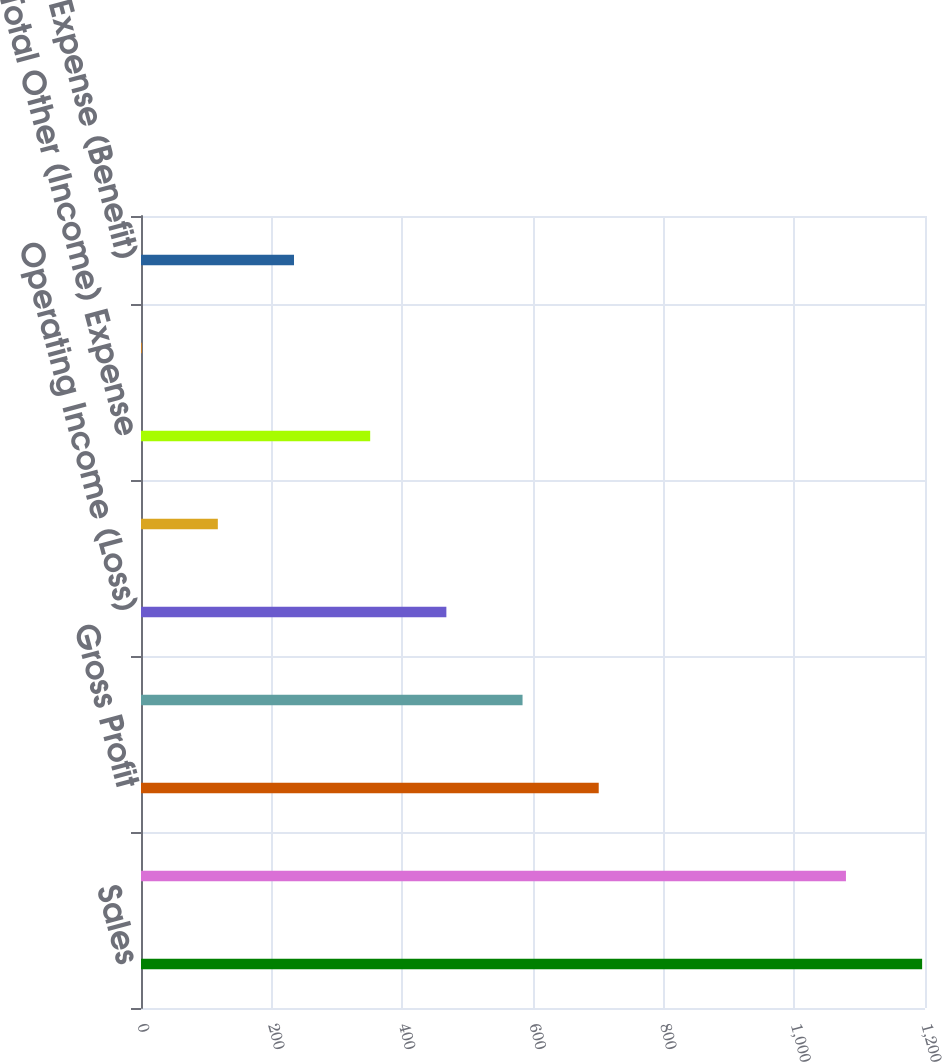Convert chart to OTSL. <chart><loc_0><loc_0><loc_500><loc_500><bar_chart><fcel>Sales<fcel>Cost of Sales<fcel>Gross Profit<fcel>Selling general and<fcel>Operating Income (Loss)<fcel>Equity in net earnings of<fcel>Total Other (Income) Expense<fcel>Income (Loss) from Continuing<fcel>Income Tax Expense (Benefit)<nl><fcel>1195.6<fcel>1079<fcel>700.6<fcel>584<fcel>467.4<fcel>117.6<fcel>350.8<fcel>1<fcel>234.2<nl></chart> 